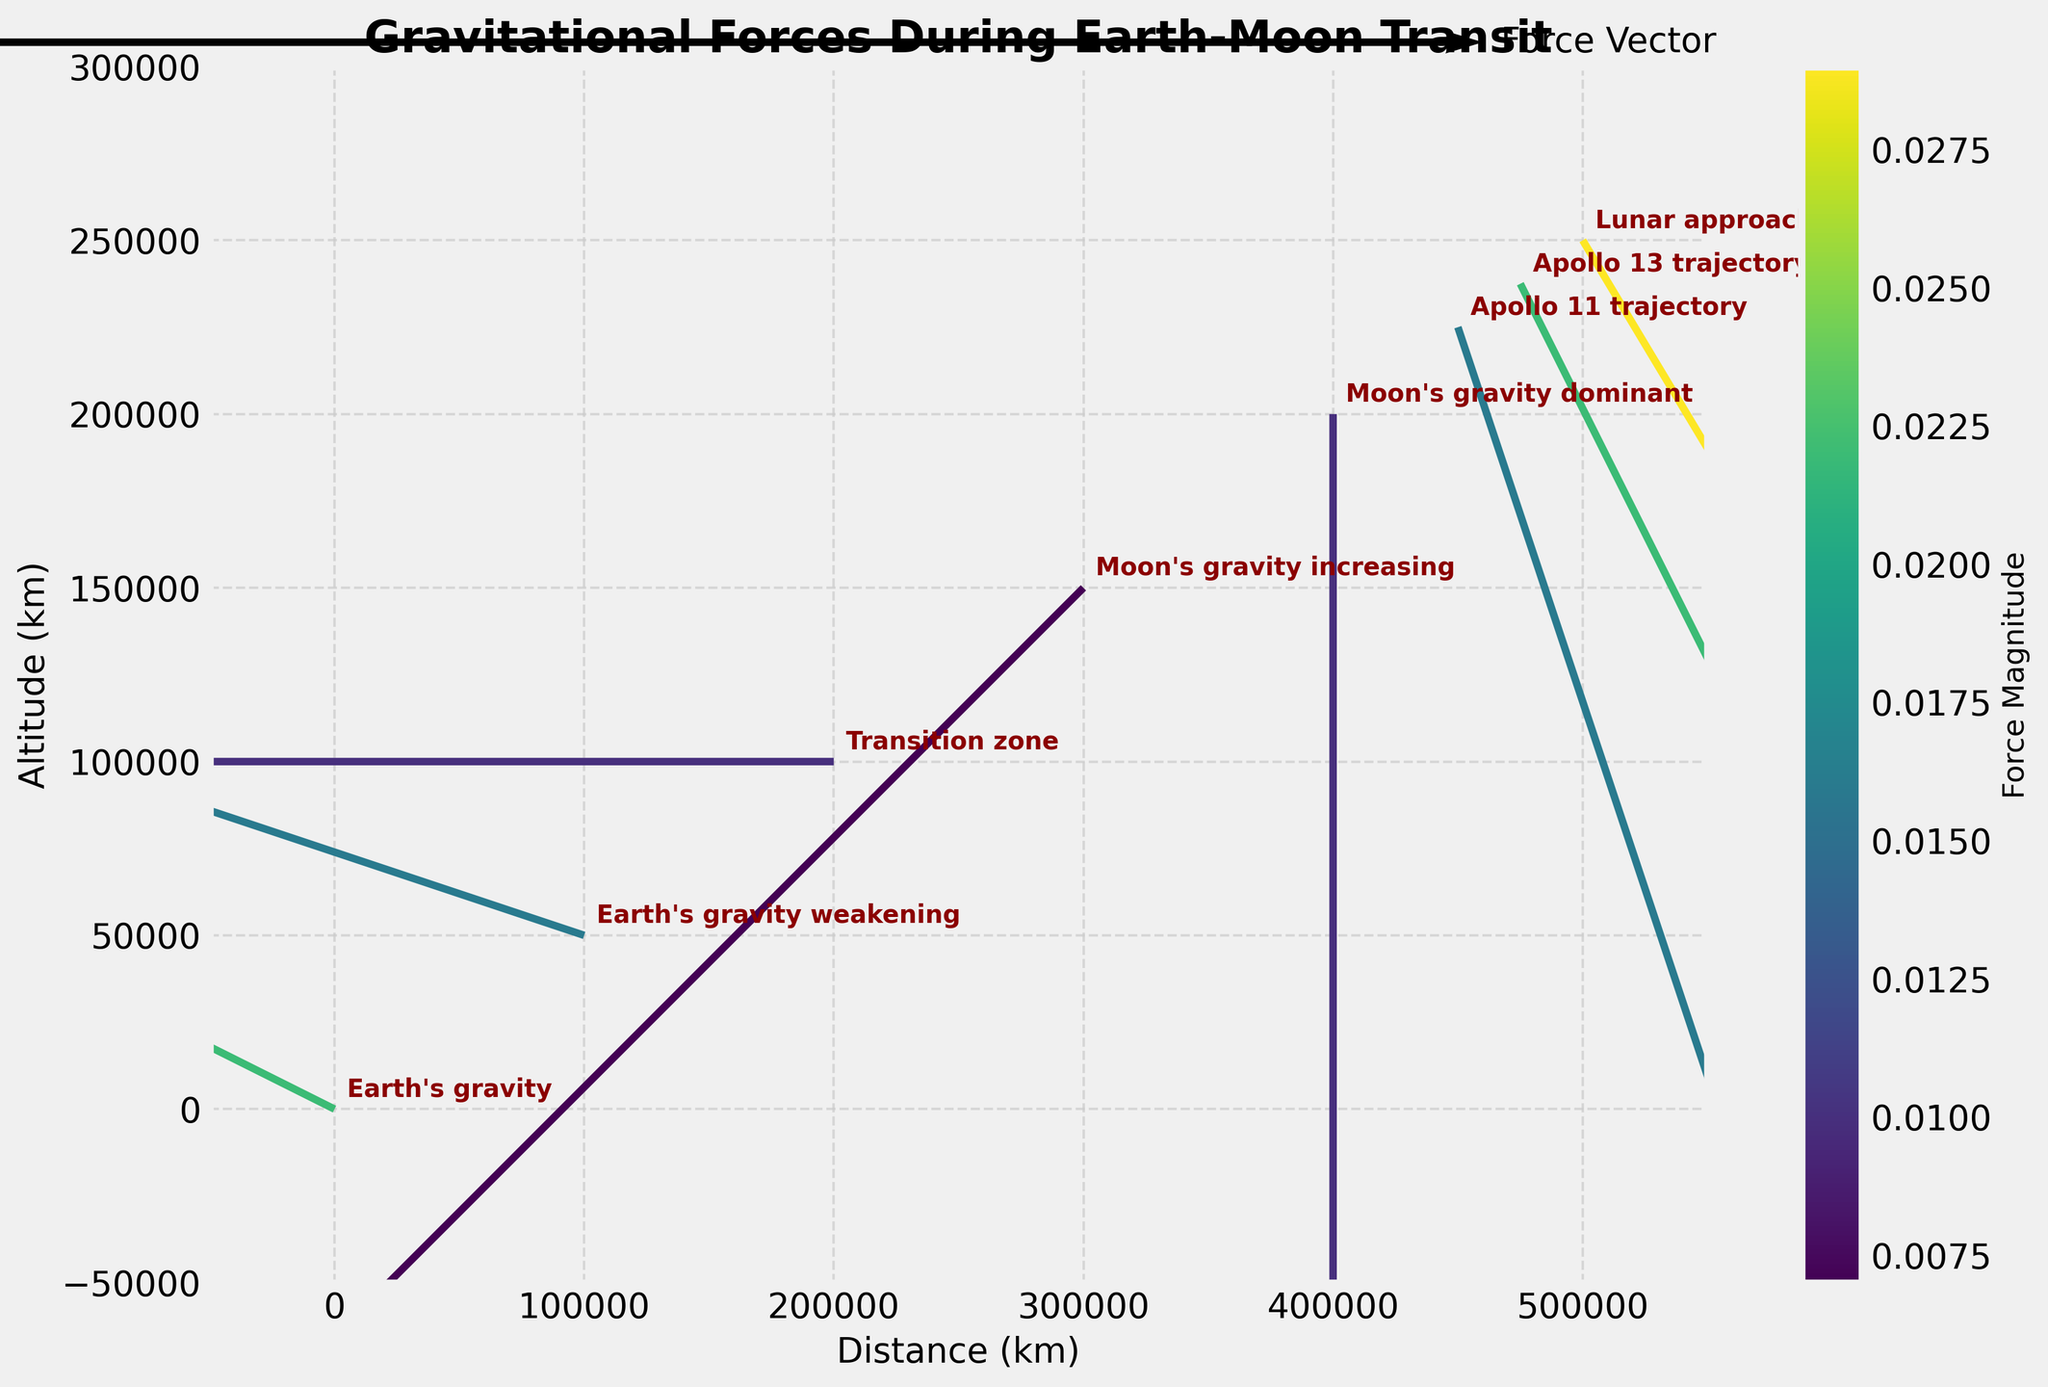What is the title of the plot? The title of the plot is usually prominently displayed at the top of the figure. It provides a summary of what the plot is about. In this case, the title of the plot is "Gravitational Forces During Earth-Moon Transit."
Answer: Gravitational Forces During Earth-Moon Transit How many data points are plotted in the figure? By counting the number of arrows (or vector origins), you can determine the number of data points plotted. In this plot, each arrow represents a data point. There are eight such points.
Answer: 8 Which gravitational force is dominant at a distance of 400,000 km in x-axis and 200,000 km in y-axis? The plot includes annotations that describe the gravitational phase at each data point. By locating the point at (400,000 km, 200,000 km) and reading the annotation, you can see that "Moon's gravity dominant" is the gravitational force at that point.
Answer: Moon's gravity What's the direction of the force vector at (300,000 km, 150,000 km)? By looking at the direction of the arrow at the specified coordinates, you can see that the vector is pointing approximately down-left, indicating a vector with components (-0.005, -0.005).
Answer: Down-left Which phase shows the greatest magnitude of force? The color of the vectors corresponds to the force magnitude, and a colorbar is provided for reference. The highest magnitude will correspond to the brightest color indicator. According to the list, "Lunar approach" at (500,000 km, 250,000 km) has the greatest magnitude of 0.029.
Answer: Lunar approach Compare the force magnitude between (100,000 km, 50,000 km) and (300,000 km, 150,000 km). Which one is greater? Checking the values provided for these coordinates, the magnitudes are 0.016 and 0.007, respectively. Therefore, the force magnitude at (100,000 km, 50,000 km) is greater than at (300,000 km, 150,000 km).
Answer: (100,000 km, 50,000 km) What can you say about the transition of gravitational forces from Earth's gravity to Moon's gravity? By analyzing the annotations, you can see that the plot transitions from "Earth's gravity" to "Earth's gravity weakening," "Transition zone," "Moon's gravity increasing," and finally "Moon's gravity dominant." This indicates a gradual shift in gravitational dominance from Earth to the Moon as the spacecraft moves closer to the Moon.
Answer: Gradual shift from Earth to Moon How does the direction of the force vector change as the spacecraft moves from Earth to the Moon? Examining the vector directions sequentially from (0, 0) to (500,000 km, 250,000 km), the vectors initially point away from Earth and rotate to point toward the Moon as the spacecraft continues its journey.
Answer: From pointing away from Earth to pointing toward Moon 